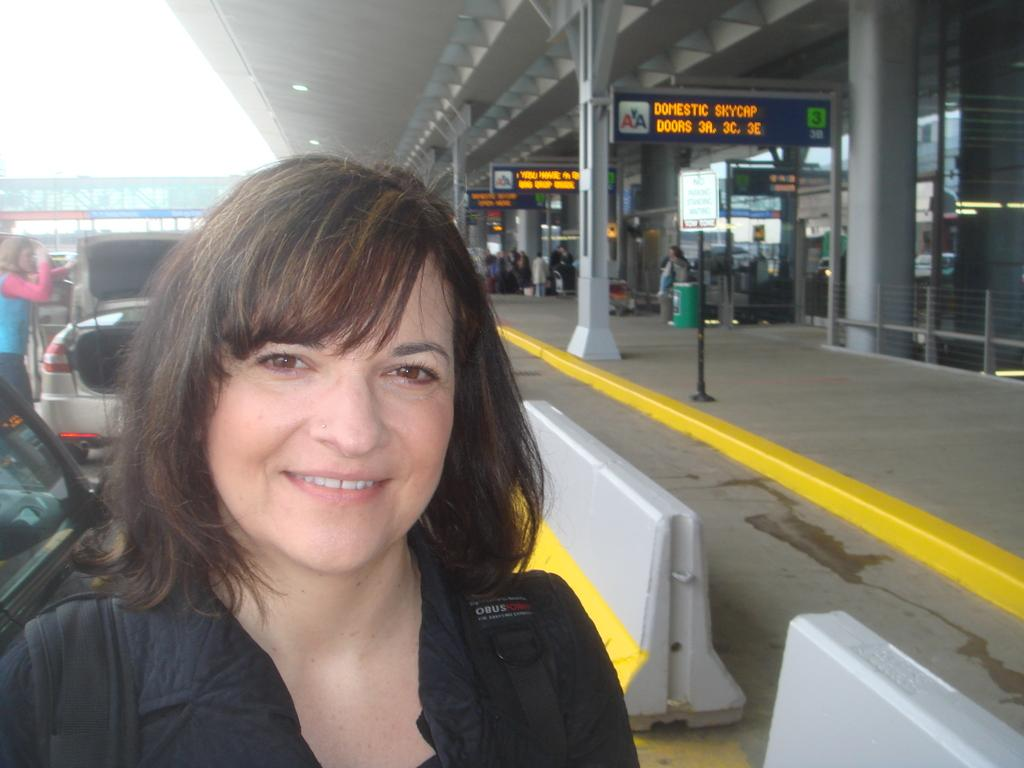Who or what can be seen in the image? There are people in the image. What else is present in the image besides people? There are vehicles, a platform, boards, railings, and a bin in the image. Can you describe the setting or location in the image? The image features a platform with railings, boards, and a bin, suggesting it might be a station or platform area. What is visible in the background of the image? The sky is visible in the background of the image. What type of knife is being used by the son in the image? There is no son or knife present in the image. 